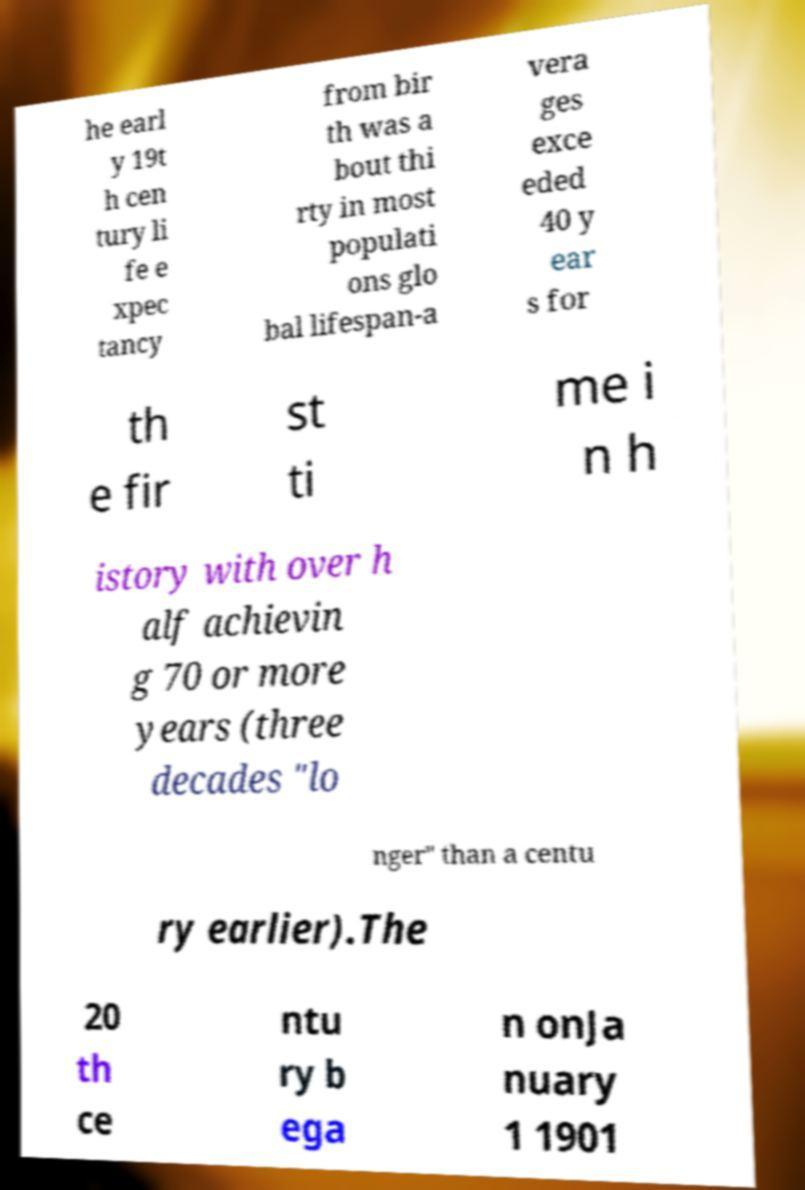For documentation purposes, I need the text within this image transcribed. Could you provide that? he earl y 19t h cen tury li fe e xpec tancy from bir th was a bout thi rty in most populati ons glo bal lifespan-a vera ges exce eded 40 y ear s for th e fir st ti me i n h istory with over h alf achievin g 70 or more years (three decades "lo nger" than a centu ry earlier).The 20 th ce ntu ry b ega n onJa nuary 1 1901 